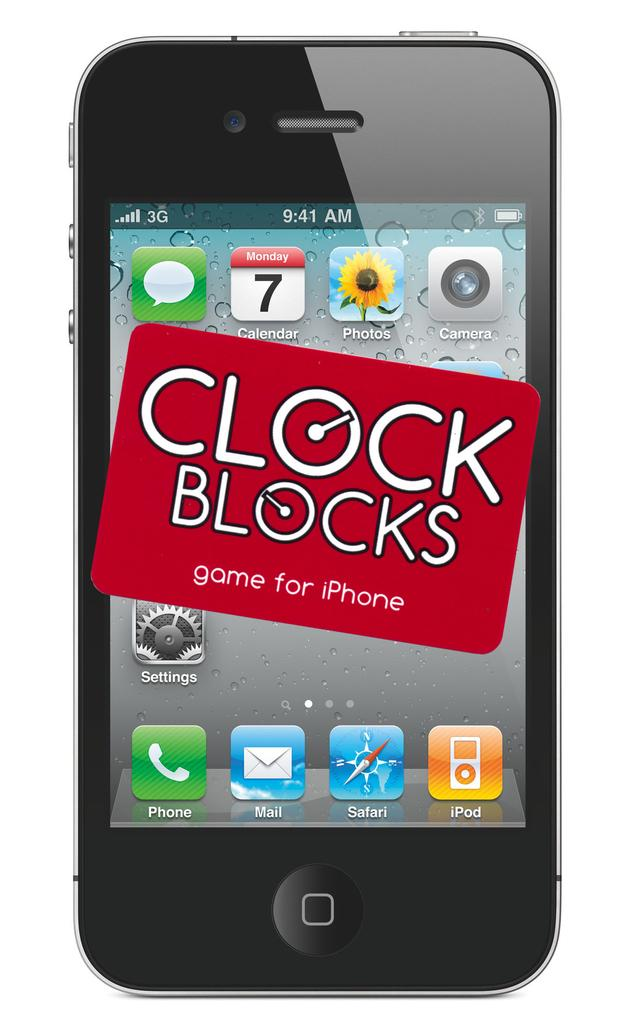<image>
Present a compact description of the photo's key features. A black cell phone that seems to only have a 3G connection is displaying the time as 9:41 AM. 